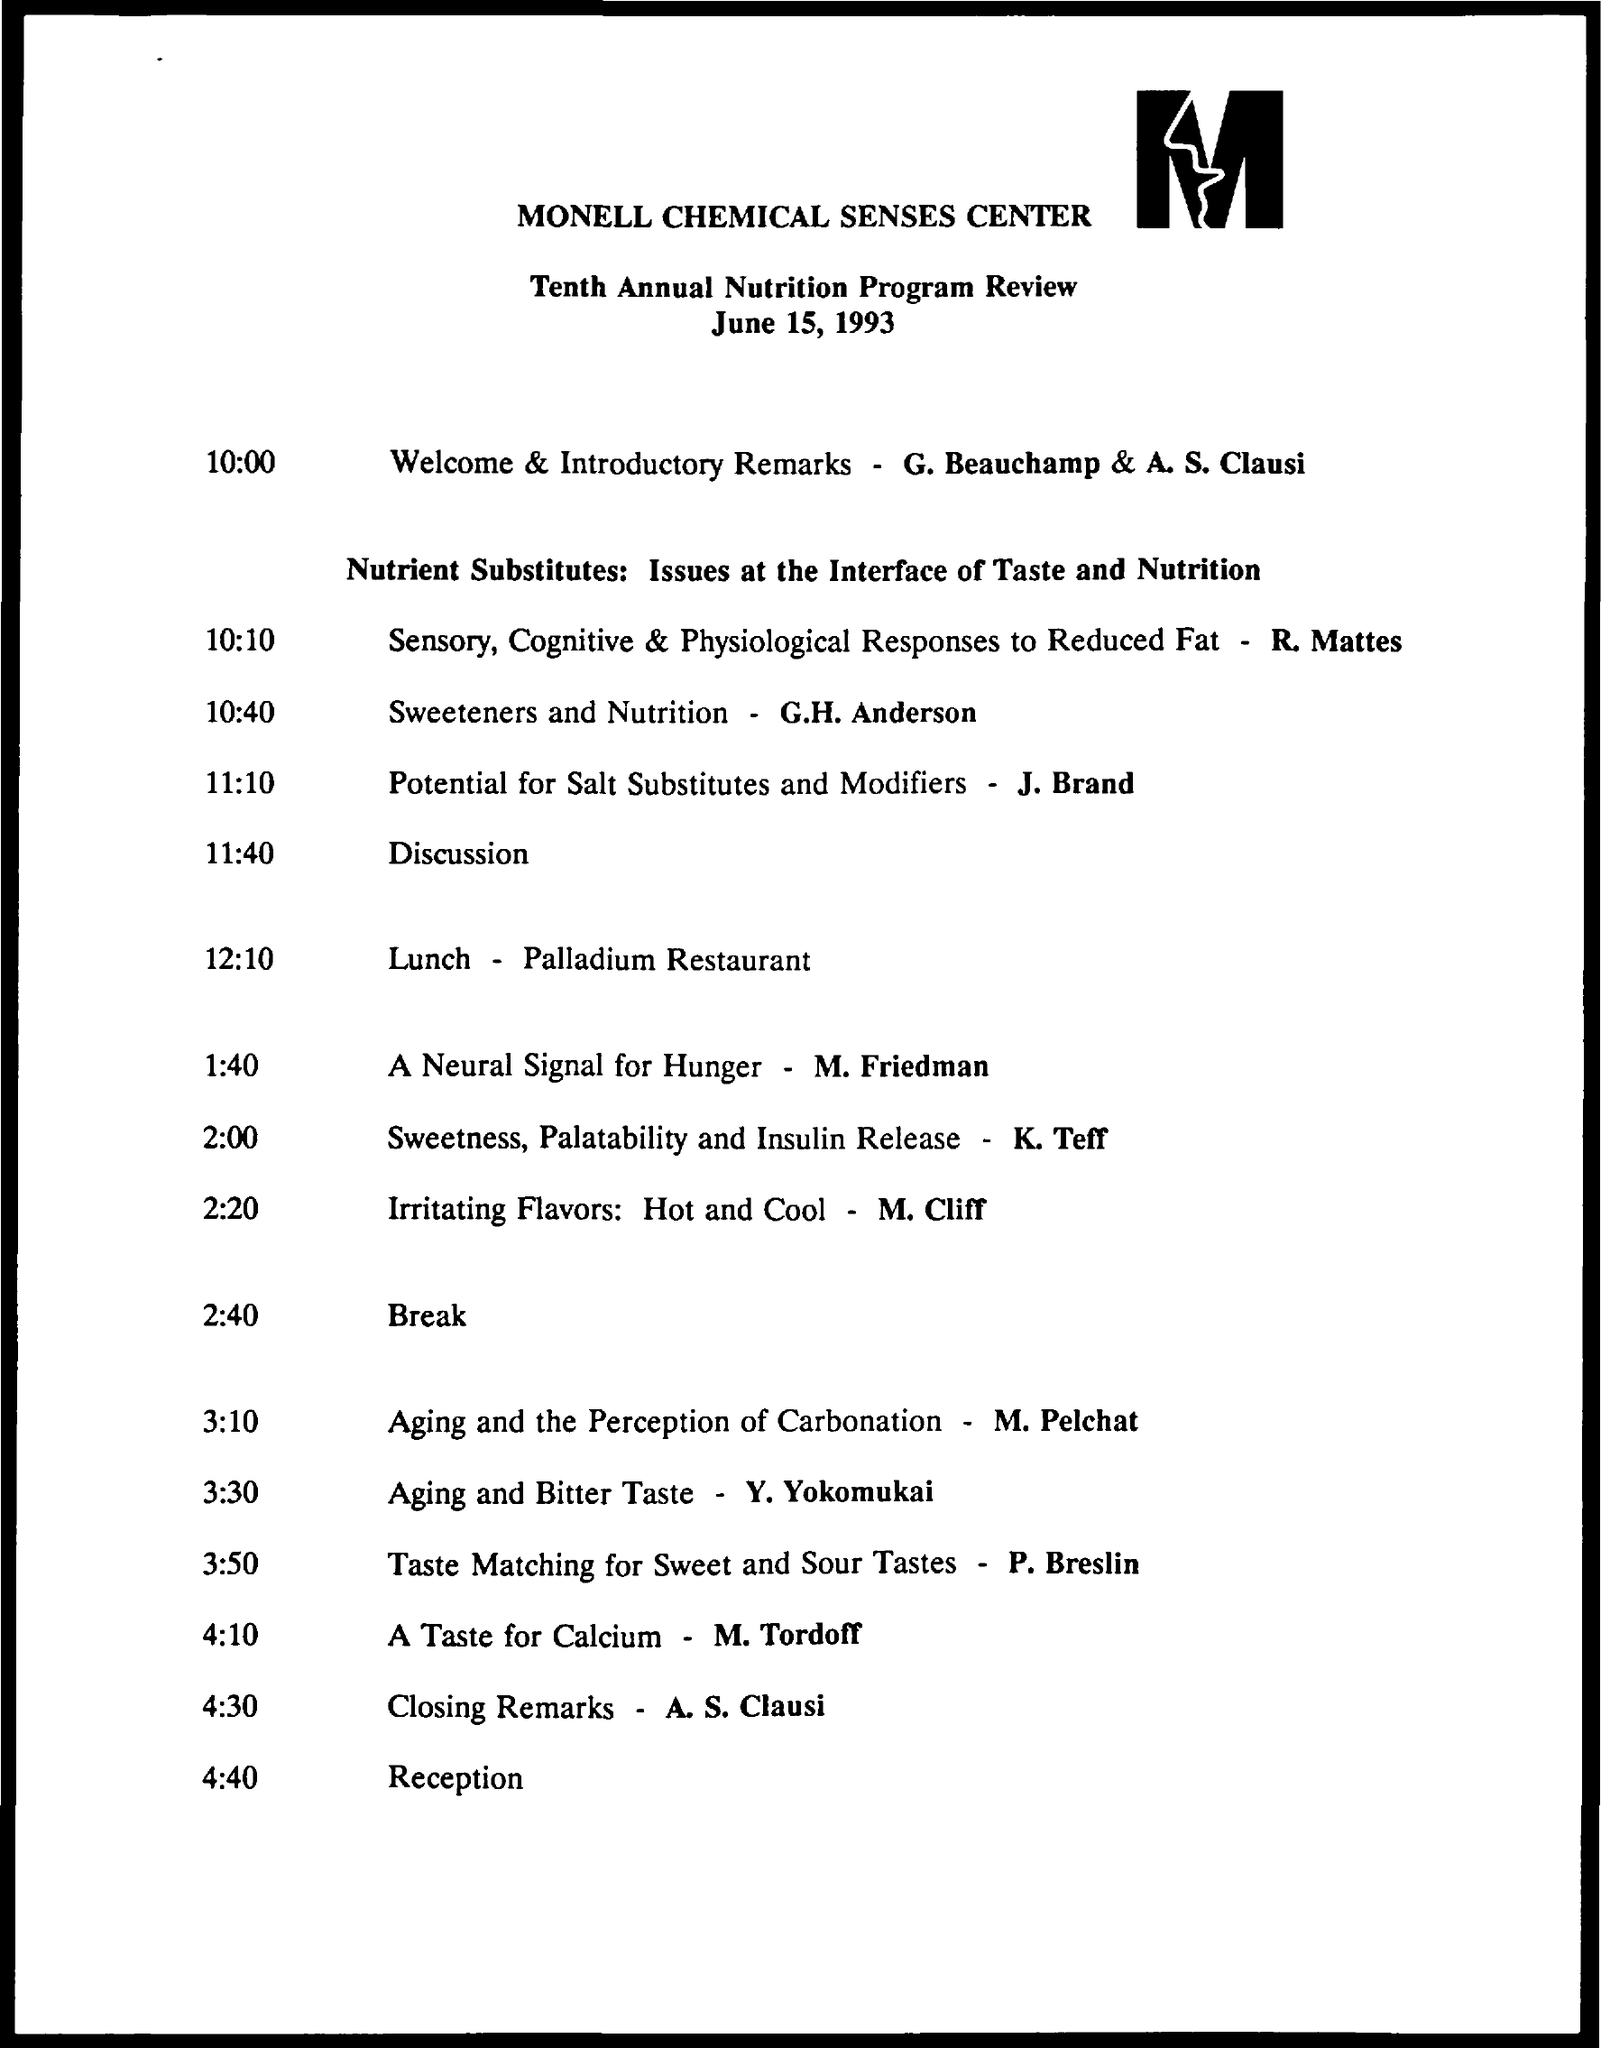What is the name of company on letter head?
Your response must be concise. Monell Chemical Senses Center. For what date this agenda is made for?
Keep it short and to the point. June 15, 1993. Who gives welcome and introductory remarks at 10:00?
Provide a succinct answer. G. Beauchamp & A.S. Clausi. A Neural Signal for Hunger is given by ?
Give a very brief answer. M. Friedman. A discussion on Potential for Salt Substitutes and  Modifiers is given by?
Ensure brevity in your answer.  J. Brand. What is the  time scheduled for lunch?
Provide a succinct answer. 12:10. What is the venue for lunch?
Offer a terse response. Palladium Restaurant. Discussion on Sweetners and Nutrition is given by?
Provide a succinct answer. G.H. Anderson. Who gives closing remarks?
Provide a succinct answer. A.S. Clausi. Discussion on A Taste for Calcium is given by?
Offer a terse response. M. Tordoff. 